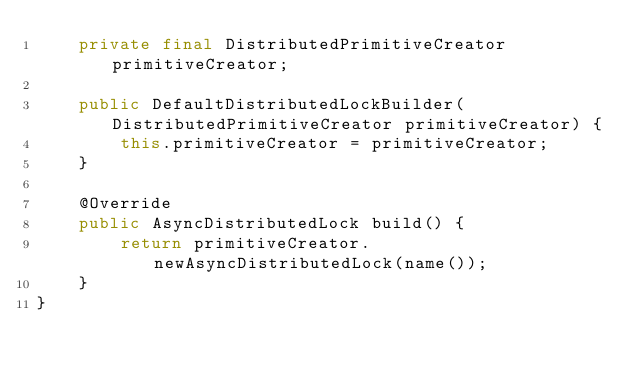Convert code to text. <code><loc_0><loc_0><loc_500><loc_500><_Java_>    private final DistributedPrimitiveCreator primitiveCreator;

    public DefaultDistributedLockBuilder(DistributedPrimitiveCreator primitiveCreator) {
        this.primitiveCreator = primitiveCreator;
    }

    @Override
    public AsyncDistributedLock build() {
        return primitiveCreator.newAsyncDistributedLock(name());
    }
}
</code> 